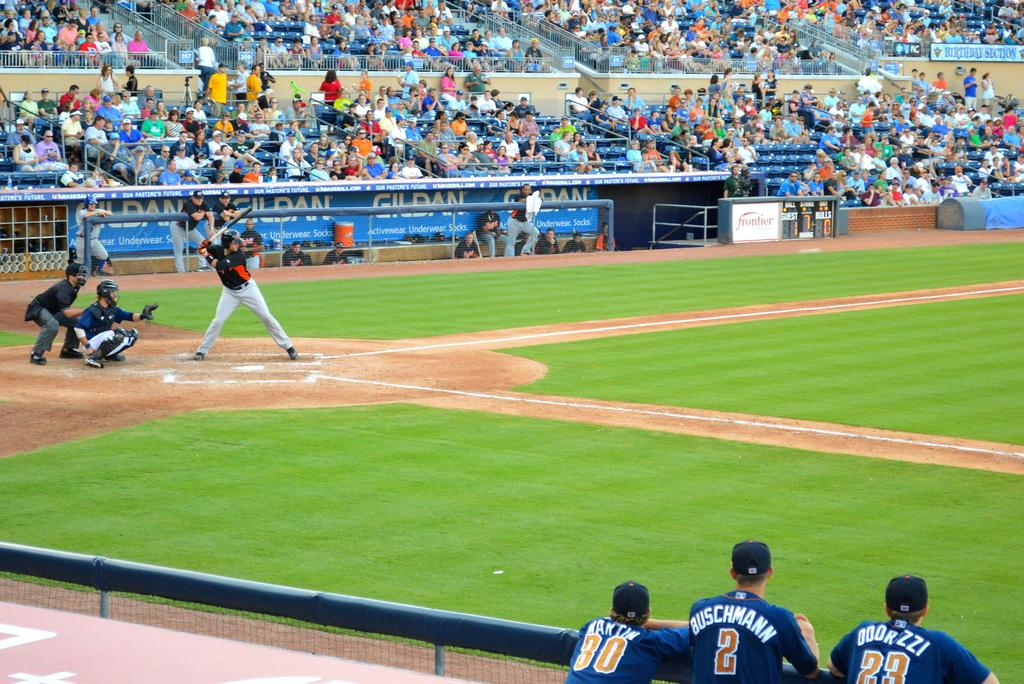<image>
Offer a succinct explanation of the picture presented. The player Buschmann stands with two others watching his team mates play. 